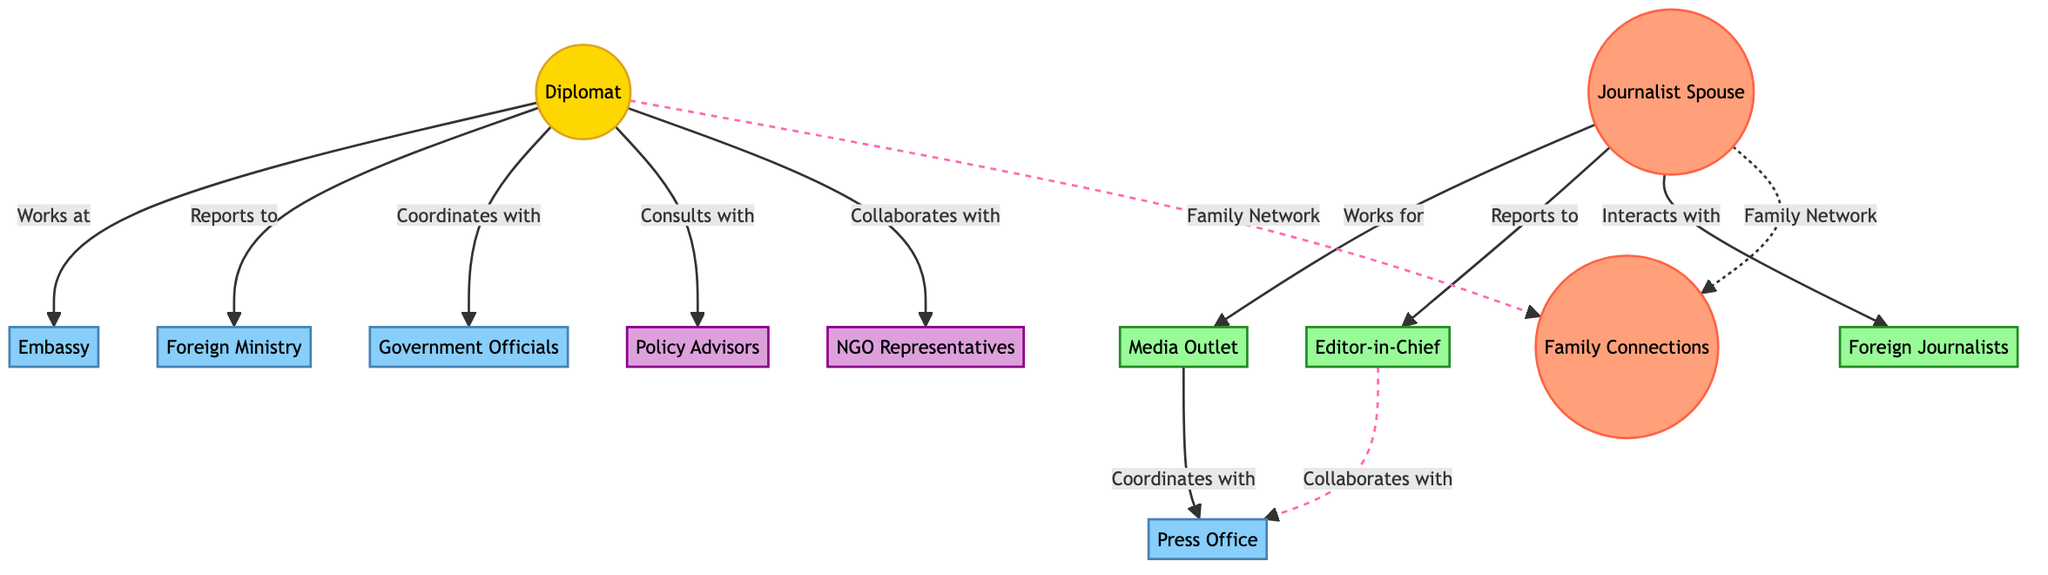What is the primary role of the diplomat? The diplomat's primary role is to work at the embassy, which is indicated by the line connecting the diplomat to the embassy node labeled "Works at."
Answer: Works at the embassy How many family connections are indicated in the diagram? The diagram shows one node representing "Family Connections," illustrating the relationships stemming from both the diplomat and the journalist spouse, thus totaling one connection.
Answer: One Which node represents foreign journalists? The node labeled "Foreign Journalists" represents this group, as indicated by its label on the diagram.
Answer: Foreign Journalists Name the media outlet that the journalist spouse works for. The node labeled "Media Outlet" is the specific outlet that the journalist spouse is associated with according to the connections in the diagram.
Answer: Media Outlet What is the relationship between the diplomat and policy advisors? The relationship is described by the label "Consults with," which indicates that the diplomat interacts with policy advisors in a consulting capacity.
Answer: Consults with How do the diplomat and the journalist spouse interact within their family network? Both the diplomat and the journalist spouse connect to the "Family Connections" node, indicating that they share a familial relationship that allows for networking between their professional and family lives.
Answer: Family Network What is the coordinating body for the media outlet? The coordinating body for the media outlet is labeled as the "Press Office," showing its functional alignment in the media network depicted in the diagram.
Answer: Press Office How many media-related nodes are illustrated in the diagram? The diagram contains four media-related nodes: "Media Outlet," "Editor-in-Chief," "Foreign Journalists," and "Press Office," adding up to a total of four specific media-focused entities.
Answer: Four What type of influence does the journalist spouse have on the family network? The influence is conveyed by the dashed line labeled "Family Network," which indicates a connection showing the spouse's role within the family's broader media connections.
Answer: Family Network 